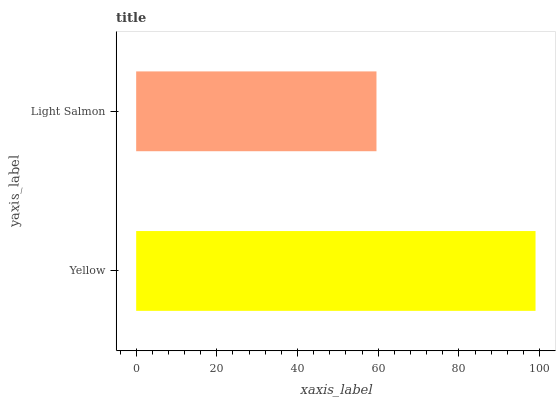Is Light Salmon the minimum?
Answer yes or no. Yes. Is Yellow the maximum?
Answer yes or no. Yes. Is Light Salmon the maximum?
Answer yes or no. No. Is Yellow greater than Light Salmon?
Answer yes or no. Yes. Is Light Salmon less than Yellow?
Answer yes or no. Yes. Is Light Salmon greater than Yellow?
Answer yes or no. No. Is Yellow less than Light Salmon?
Answer yes or no. No. Is Yellow the high median?
Answer yes or no. Yes. Is Light Salmon the low median?
Answer yes or no. Yes. Is Light Salmon the high median?
Answer yes or no. No. Is Yellow the low median?
Answer yes or no. No. 